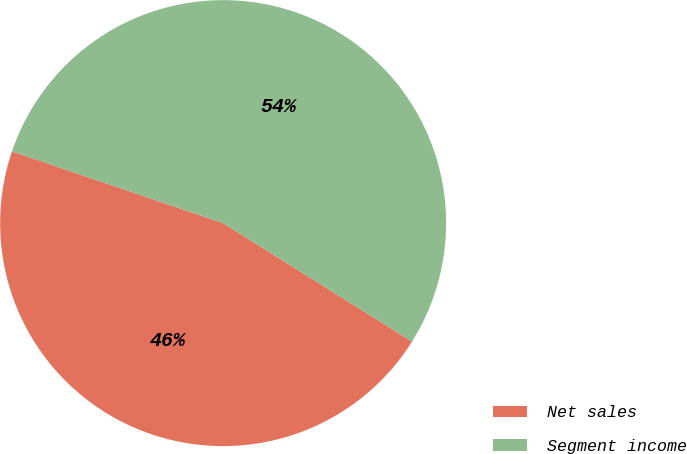Convert chart. <chart><loc_0><loc_0><loc_500><loc_500><pie_chart><fcel>Net sales<fcel>Segment income<nl><fcel>46.3%<fcel>53.7%<nl></chart> 